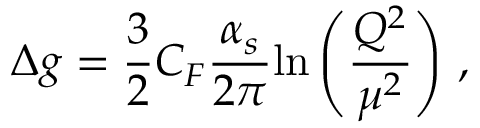<formula> <loc_0><loc_0><loc_500><loc_500>\Delta g = { \frac { 3 } { 2 } } C _ { F } { \frac { \alpha _ { s } } { 2 \pi } } { \ln \left ( \frac { Q ^ { 2 } } { \mu ^ { 2 } } \right ) } \ ,</formula> 